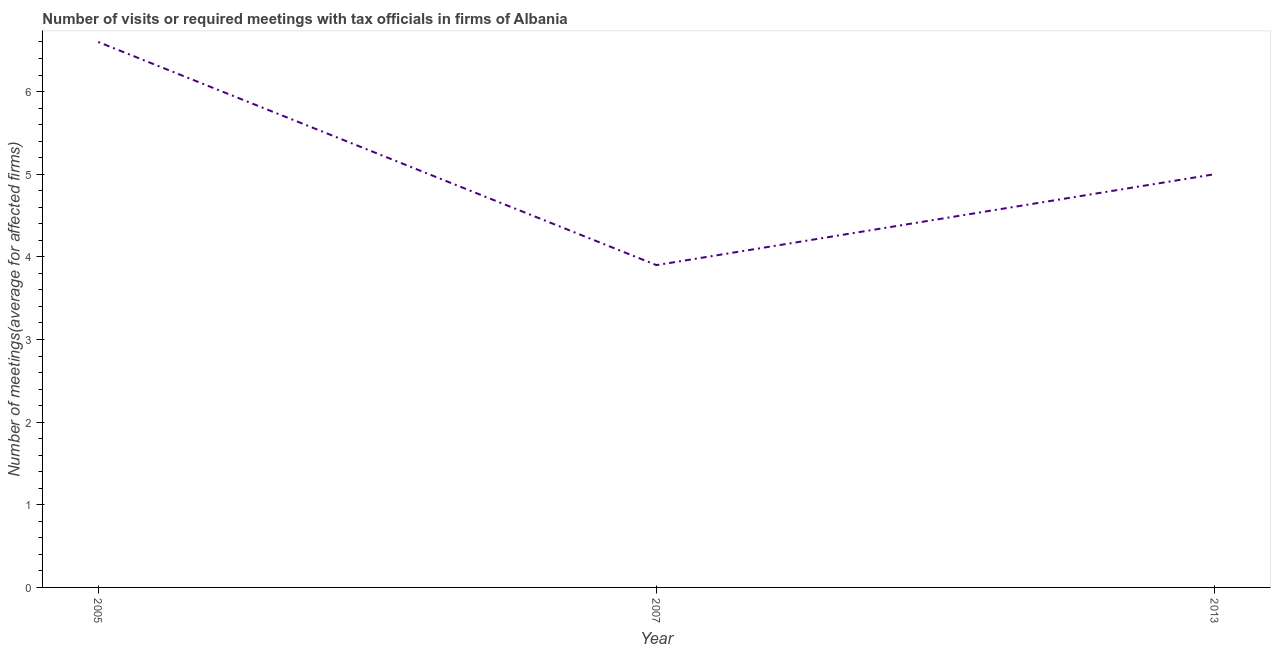In which year was the number of required meetings with tax officials minimum?
Your answer should be compact. 2007. What is the difference between the number of required meetings with tax officials in 2007 and 2013?
Make the answer very short. -1.1. What is the average number of required meetings with tax officials per year?
Your answer should be very brief. 5.17. In how many years, is the number of required meetings with tax officials greater than 0.8 ?
Give a very brief answer. 3. What is the ratio of the number of required meetings with tax officials in 2007 to that in 2013?
Ensure brevity in your answer.  0.78. Is the number of required meetings with tax officials in 2007 less than that in 2013?
Ensure brevity in your answer.  Yes. What is the difference between the highest and the second highest number of required meetings with tax officials?
Your answer should be compact. 1.6. Is the sum of the number of required meetings with tax officials in 2005 and 2007 greater than the maximum number of required meetings with tax officials across all years?
Offer a very short reply. Yes. What is the difference between the highest and the lowest number of required meetings with tax officials?
Provide a succinct answer. 2.7. In how many years, is the number of required meetings with tax officials greater than the average number of required meetings with tax officials taken over all years?
Ensure brevity in your answer.  1. Does the number of required meetings with tax officials monotonically increase over the years?
Make the answer very short. No. How many years are there in the graph?
Provide a succinct answer. 3. What is the difference between two consecutive major ticks on the Y-axis?
Your answer should be compact. 1. Are the values on the major ticks of Y-axis written in scientific E-notation?
Your answer should be compact. No. Does the graph contain grids?
Your response must be concise. No. What is the title of the graph?
Provide a succinct answer. Number of visits or required meetings with tax officials in firms of Albania. What is the label or title of the X-axis?
Provide a short and direct response. Year. What is the label or title of the Y-axis?
Provide a succinct answer. Number of meetings(average for affected firms). What is the Number of meetings(average for affected firms) of 2005?
Offer a very short reply. 6.6. What is the Number of meetings(average for affected firms) in 2013?
Ensure brevity in your answer.  5. What is the difference between the Number of meetings(average for affected firms) in 2005 and 2013?
Provide a succinct answer. 1.6. What is the difference between the Number of meetings(average for affected firms) in 2007 and 2013?
Provide a succinct answer. -1.1. What is the ratio of the Number of meetings(average for affected firms) in 2005 to that in 2007?
Ensure brevity in your answer.  1.69. What is the ratio of the Number of meetings(average for affected firms) in 2005 to that in 2013?
Make the answer very short. 1.32. What is the ratio of the Number of meetings(average for affected firms) in 2007 to that in 2013?
Your answer should be very brief. 0.78. 